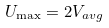<formula> <loc_0><loc_0><loc_500><loc_500>U _ { \max } = 2 V _ { a v g }</formula> 